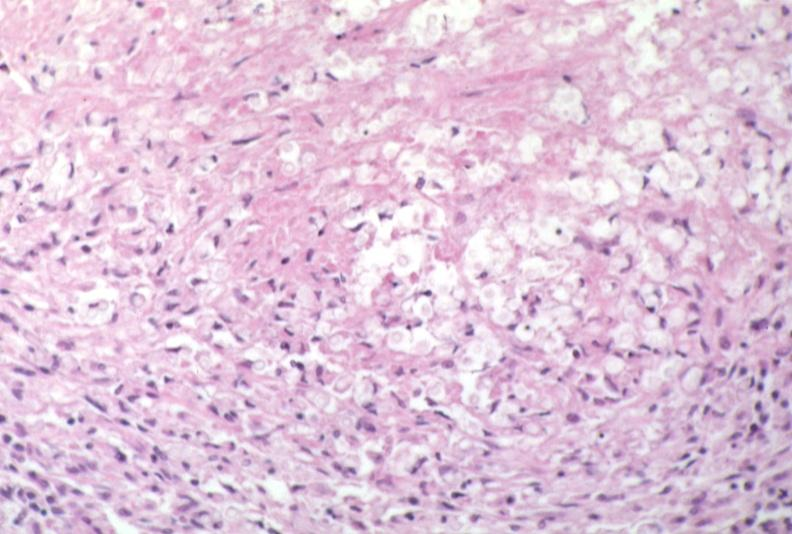does this image show lymph node, cryptococcosis?
Answer the question using a single word or phrase. Yes 